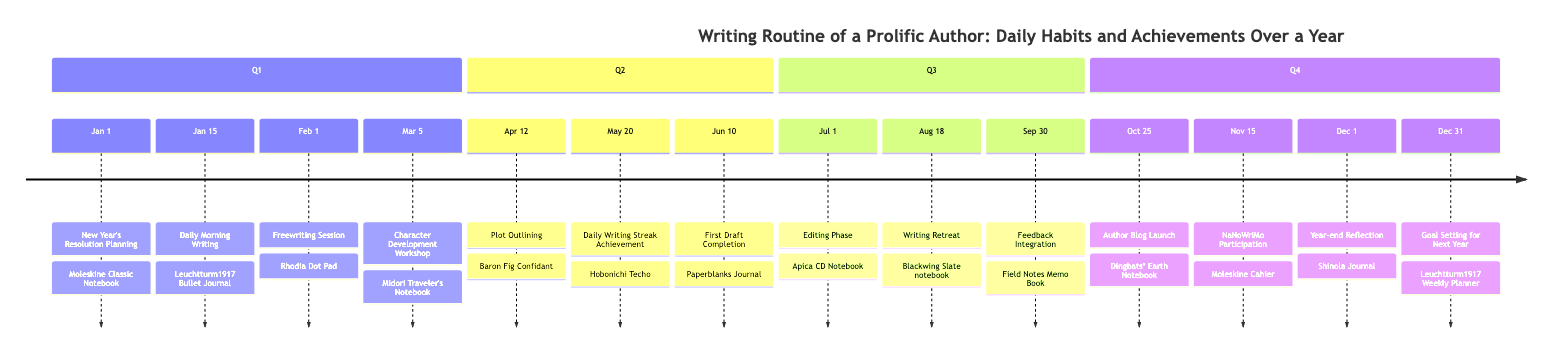What activity took place on January 15? The diagram indicates that on January 15, the activity was "Daily Morning Writing." This is directly labeled under that date.
Answer: Daily Morning Writing How many activities are recorded in Q3? By reviewing the diagram, it is noted that Q3 includes three activities: "Editing Phase," "Writing Retreat," and "Feedback Integration." Thus, the total count is three.
Answer: 3 What notebook was used for the Year-end Reflection? The diagram specifies that for the Year-end Reflection on December 1, a "Shinola Journal" was used. This information is explicitly noted alongside the activity.
Answer: Shinola Journal Which month had the achievement of a daily writing streak? Looking at the diagram, the achievement of a daily writing streak occurred on May 20. The date is clearly stated in the corresponding section of Q2.
Answer: May What is the significance of October 25 in the timeline? On October 25, the activity was the "Author Blog Launch." This is an important milestone as represented on the timeline, and the detail is provided directly beneath the date.
Answer: Author Blog Launch Which writing tool was employed during the Character Development Workshop? The diagram shows that during the Character Development Workshop on March 5, a "Midori Traveler's Notebook" was used for note-taking. This is clearly stated in the activity description.
Answer: Midori Traveler's Notebook What common activity occurs at the beginning and end of the year? Checking the timeline, both the "New Year's Resolution Planning" on January 1 and "Goal Setting for Next Year" on December 31 involve setting goals. This shows a cyclical approach to writing intentions.
Answer: Setting goals During which month did the author complete the first draft? The timeline identifies that the first draft was completed on June 10. This date is specifically noted in Q2 of the diagram.
Answer: June How long was the writing retreat attended? According to the diagram, the writing retreat occurred over a span of three days on August 18. This detail is contained within the activity description for that date.
Answer: 3 days 